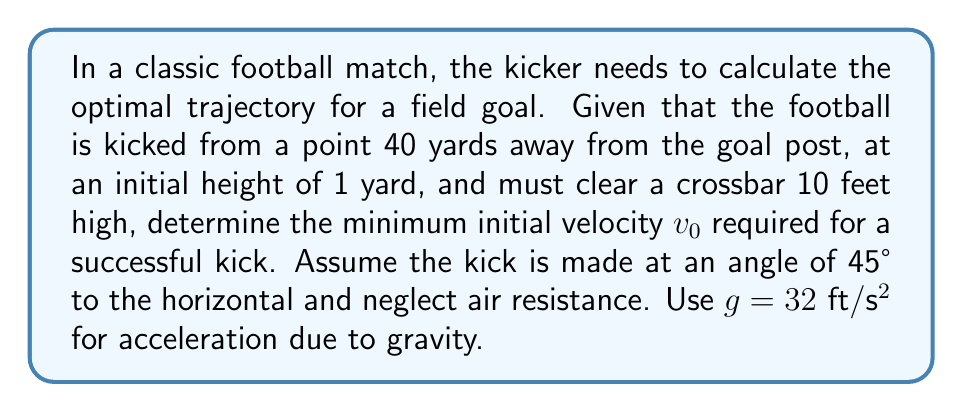Give your solution to this math problem. To solve this problem, we'll use the equations of motion for projectile motion and multivariable calculus concepts. Let's break it down step by step:

1) First, let's define our coordinate system:
   - x-axis: horizontal distance
   - y-axis: vertical height
   - Origin: point of kick

2) The parametric equations for the trajectory of the football are:

   $$x(t) = v_0 \cos(45°) \cdot t$$
   $$y(t) = v_0 \sin(45°) \cdot t - \frac{1}{2}gt^2 + 1$$

   Where the +1 accounts for the initial height of 1 yard.

3) We know that the football needs to clear the crossbar at x = 40 yards = 120 feet. Let's find the time t when this occurs:

   $$120 = v_0 \cos(45°) \cdot t$$
   $$t = \frac{120}{v_0 \cos(45°)}$$

4) At this time t, the height y must be at least 10 feet. We can express this as an inequality:

   $$y(t) = v_0 \sin(45°) \cdot \frac{120}{v_0 \cos(45°)} - \frac{1}{2}g\left(\frac{120}{v_0 \cos(45°)}\right)^2 + 1 \geq 10$$

5) Simplify using $\cos(45°) = \sin(45°) = \frac{1}{\sqrt{2}}$:

   $$120 - \frac{1}{2}g\left(\frac{120\sqrt{2}}{v_0}\right)^2 + 1 \geq 10$$

6) Solve this inequality for $v_0$:

   $$\frac{1}{2}g\left(\frac{120\sqrt{2}}{v_0}\right)^2 \leq 111$$
   $$\left(\frac{120\sqrt{2}}{v_0}\right)^2 \leq \frac{222}{g}$$
   $$v_0^2 \geq \frac{(120\sqrt{2})^2 \cdot g}{222}$$
   $$v_0 \geq \sqrt{\frac{(120\sqrt{2})^2 \cdot 32}{222}} \approx 64.94 \text{ ft/s}$$

7) Convert to miles per hour:

   $$v_0 \geq 64.94 \cdot \frac{3600}{5280} \approx 44.28 \text{ mph}$$
Answer: The minimum initial velocity required for a successful kick is approximately 44.28 mph or 64.94 ft/s. 